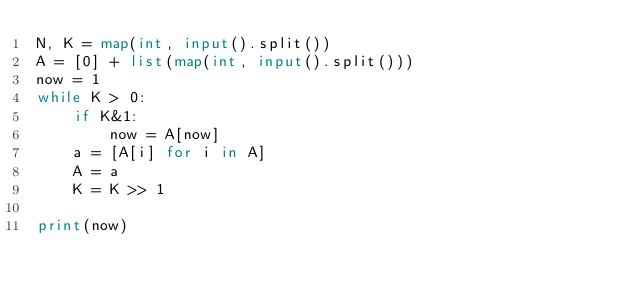Convert code to text. <code><loc_0><loc_0><loc_500><loc_500><_Python_>N, K = map(int, input().split())
A = [0] + list(map(int, input().split()))
now = 1
while K > 0:
    if K&1:
        now = A[now]
    a = [A[i] for i in A]
    A = a
    K = K >> 1

print(now)
</code> 